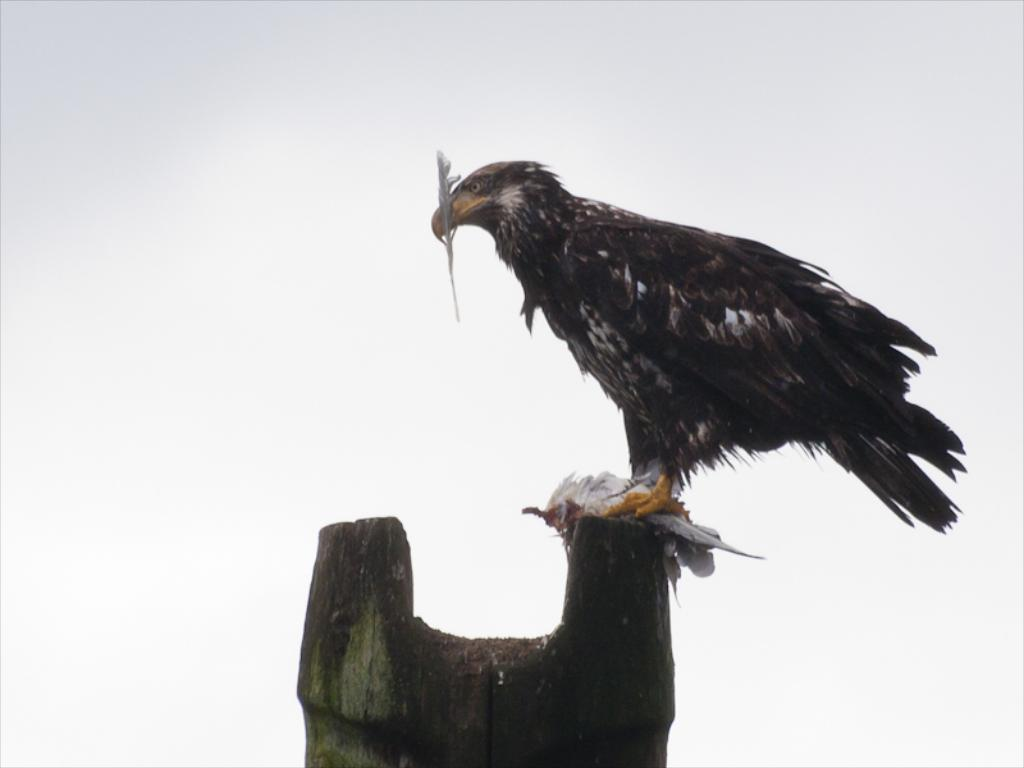What type of animal is in the image? There is an eagle in the image. What is the eagle standing on in the image? The eagle is standing on a wooden object. What scientific discovery is being made in the image? There is no scientific discovery being made in the image; it features an eagle standing on a wooden object. What type of sign can be seen in the image? There is no sign present in the image; it features an eagle standing on a wooden object. What type of ocean creature can be seen in the image? There is no ocean creature present in the image; it features an eagle standing on a wooden object. 